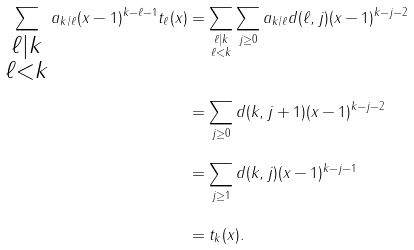<formula> <loc_0><loc_0><loc_500><loc_500>\sum _ { \substack { \ell | k \\ \ell < k } } a _ { k / \ell } ( x - 1 ) ^ { k - \ell - 1 } t _ { \ell } ( x ) & = \sum _ { \substack { \ell | k \\ \ell < k } } \sum _ { j \geq 0 } a _ { k / \ell } d ( \ell , j ) ( x - 1 ) ^ { k - j - 2 } \\ & = \sum _ { j \geq 0 } d ( k , j + 1 ) ( x - 1 ) ^ { k - j - 2 } \\ & = \sum _ { j \geq 1 } d ( k , j ) ( x - 1 ) ^ { k - j - 1 } \\ & = t _ { k } ( x ) .</formula> 